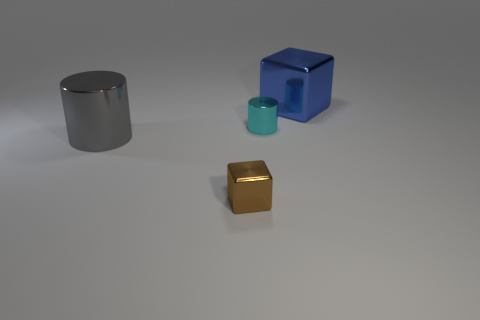Are these objects capable of moving on their own? No, the objects in the image are static and inanimate. They would require an external force to change their positions within the space. 